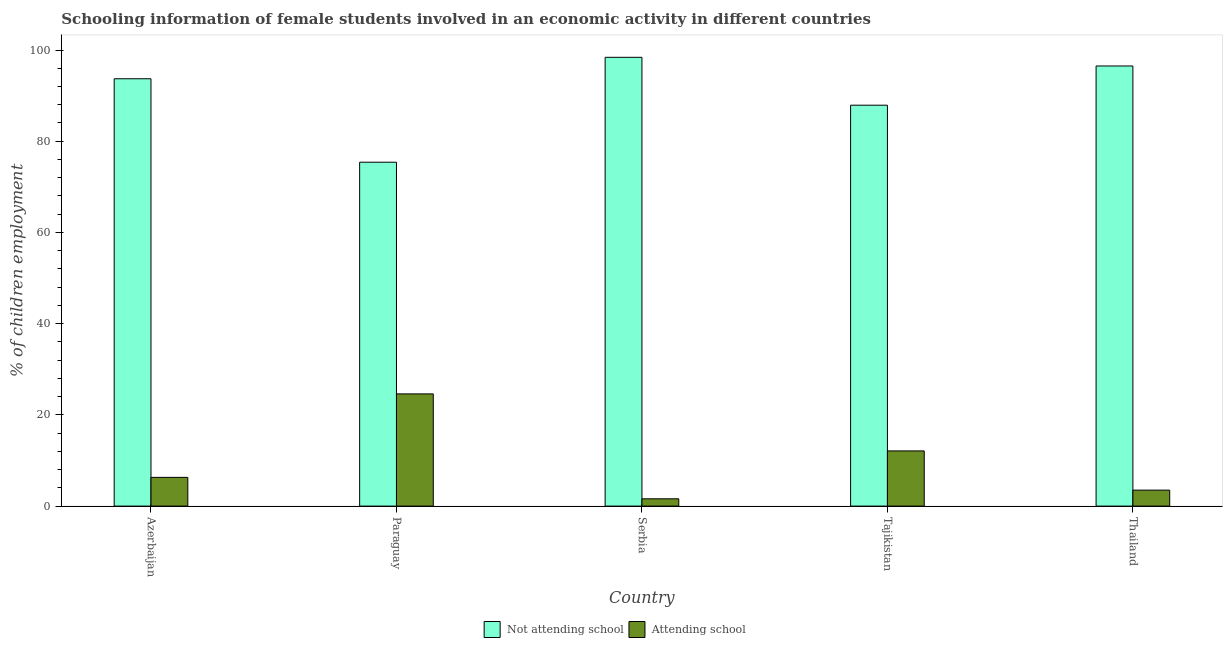Are the number of bars per tick equal to the number of legend labels?
Your answer should be compact. Yes. Are the number of bars on each tick of the X-axis equal?
Keep it short and to the point. Yes. How many bars are there on the 3rd tick from the left?
Ensure brevity in your answer.  2. What is the label of the 1st group of bars from the left?
Give a very brief answer. Azerbaijan. In how many cases, is the number of bars for a given country not equal to the number of legend labels?
Your answer should be compact. 0. What is the percentage of employed females who are not attending school in Thailand?
Offer a very short reply. 96.5. Across all countries, what is the maximum percentage of employed females who are attending school?
Your answer should be very brief. 24.6. Across all countries, what is the minimum percentage of employed females who are not attending school?
Your answer should be compact. 75.4. In which country was the percentage of employed females who are attending school maximum?
Offer a terse response. Paraguay. In which country was the percentage of employed females who are not attending school minimum?
Ensure brevity in your answer.  Paraguay. What is the total percentage of employed females who are not attending school in the graph?
Your response must be concise. 451.9. What is the difference between the percentage of employed females who are not attending school in Paraguay and that in Serbia?
Your answer should be compact. -23. What is the difference between the percentage of employed females who are attending school in Thailand and the percentage of employed females who are not attending school in Azerbaijan?
Your answer should be compact. -90.2. What is the average percentage of employed females who are attending school per country?
Provide a succinct answer. 9.62. What is the difference between the percentage of employed females who are not attending school and percentage of employed females who are attending school in Azerbaijan?
Ensure brevity in your answer.  87.4. What is the ratio of the percentage of employed females who are not attending school in Serbia to that in Tajikistan?
Ensure brevity in your answer.  1.12. Is the percentage of employed females who are attending school in Serbia less than that in Tajikistan?
Offer a very short reply. Yes. Is the difference between the percentage of employed females who are attending school in Paraguay and Serbia greater than the difference between the percentage of employed females who are not attending school in Paraguay and Serbia?
Offer a terse response. Yes. What is the difference between the highest and the second highest percentage of employed females who are not attending school?
Your response must be concise. 1.9. What does the 1st bar from the left in Azerbaijan represents?
Offer a very short reply. Not attending school. What does the 2nd bar from the right in Serbia represents?
Ensure brevity in your answer.  Not attending school. How many countries are there in the graph?
Ensure brevity in your answer.  5. Are the values on the major ticks of Y-axis written in scientific E-notation?
Offer a terse response. No. Where does the legend appear in the graph?
Make the answer very short. Bottom center. What is the title of the graph?
Your response must be concise. Schooling information of female students involved in an economic activity in different countries. What is the label or title of the X-axis?
Provide a succinct answer. Country. What is the label or title of the Y-axis?
Make the answer very short. % of children employment. What is the % of children employment in Not attending school in Azerbaijan?
Your response must be concise. 93.7. What is the % of children employment of Not attending school in Paraguay?
Your answer should be compact. 75.4. What is the % of children employment of Attending school in Paraguay?
Keep it short and to the point. 24.6. What is the % of children employment of Not attending school in Serbia?
Your response must be concise. 98.4. What is the % of children employment in Attending school in Serbia?
Make the answer very short. 1.6. What is the % of children employment of Not attending school in Tajikistan?
Make the answer very short. 87.9. What is the % of children employment of Not attending school in Thailand?
Your response must be concise. 96.5. Across all countries, what is the maximum % of children employment of Not attending school?
Your response must be concise. 98.4. Across all countries, what is the maximum % of children employment of Attending school?
Give a very brief answer. 24.6. Across all countries, what is the minimum % of children employment in Not attending school?
Your response must be concise. 75.4. What is the total % of children employment in Not attending school in the graph?
Your response must be concise. 451.9. What is the total % of children employment in Attending school in the graph?
Give a very brief answer. 48.1. What is the difference between the % of children employment of Attending school in Azerbaijan and that in Paraguay?
Make the answer very short. -18.3. What is the difference between the % of children employment of Attending school in Azerbaijan and that in Serbia?
Provide a succinct answer. 4.7. What is the difference between the % of children employment of Attending school in Azerbaijan and that in Tajikistan?
Provide a succinct answer. -5.8. What is the difference between the % of children employment of Not attending school in Paraguay and that in Serbia?
Your answer should be very brief. -23. What is the difference between the % of children employment in Attending school in Paraguay and that in Serbia?
Give a very brief answer. 23. What is the difference between the % of children employment of Attending school in Paraguay and that in Tajikistan?
Offer a terse response. 12.5. What is the difference between the % of children employment of Not attending school in Paraguay and that in Thailand?
Ensure brevity in your answer.  -21.1. What is the difference between the % of children employment in Attending school in Paraguay and that in Thailand?
Offer a terse response. 21.1. What is the difference between the % of children employment in Not attending school in Serbia and that in Tajikistan?
Make the answer very short. 10.5. What is the difference between the % of children employment in Attending school in Serbia and that in Tajikistan?
Provide a succinct answer. -10.5. What is the difference between the % of children employment of Not attending school in Serbia and that in Thailand?
Make the answer very short. 1.9. What is the difference between the % of children employment of Not attending school in Azerbaijan and the % of children employment of Attending school in Paraguay?
Ensure brevity in your answer.  69.1. What is the difference between the % of children employment in Not attending school in Azerbaijan and the % of children employment in Attending school in Serbia?
Your response must be concise. 92.1. What is the difference between the % of children employment in Not attending school in Azerbaijan and the % of children employment in Attending school in Tajikistan?
Provide a short and direct response. 81.6. What is the difference between the % of children employment of Not attending school in Azerbaijan and the % of children employment of Attending school in Thailand?
Provide a succinct answer. 90.2. What is the difference between the % of children employment in Not attending school in Paraguay and the % of children employment in Attending school in Serbia?
Make the answer very short. 73.8. What is the difference between the % of children employment in Not attending school in Paraguay and the % of children employment in Attending school in Tajikistan?
Offer a very short reply. 63.3. What is the difference between the % of children employment of Not attending school in Paraguay and the % of children employment of Attending school in Thailand?
Offer a very short reply. 71.9. What is the difference between the % of children employment in Not attending school in Serbia and the % of children employment in Attending school in Tajikistan?
Offer a terse response. 86.3. What is the difference between the % of children employment of Not attending school in Serbia and the % of children employment of Attending school in Thailand?
Offer a very short reply. 94.9. What is the difference between the % of children employment of Not attending school in Tajikistan and the % of children employment of Attending school in Thailand?
Provide a short and direct response. 84.4. What is the average % of children employment of Not attending school per country?
Give a very brief answer. 90.38. What is the average % of children employment of Attending school per country?
Give a very brief answer. 9.62. What is the difference between the % of children employment of Not attending school and % of children employment of Attending school in Azerbaijan?
Make the answer very short. 87.4. What is the difference between the % of children employment of Not attending school and % of children employment of Attending school in Paraguay?
Your response must be concise. 50.8. What is the difference between the % of children employment in Not attending school and % of children employment in Attending school in Serbia?
Ensure brevity in your answer.  96.8. What is the difference between the % of children employment of Not attending school and % of children employment of Attending school in Tajikistan?
Provide a succinct answer. 75.8. What is the difference between the % of children employment in Not attending school and % of children employment in Attending school in Thailand?
Keep it short and to the point. 93. What is the ratio of the % of children employment in Not attending school in Azerbaijan to that in Paraguay?
Provide a succinct answer. 1.24. What is the ratio of the % of children employment in Attending school in Azerbaijan to that in Paraguay?
Provide a succinct answer. 0.26. What is the ratio of the % of children employment of Not attending school in Azerbaijan to that in Serbia?
Provide a short and direct response. 0.95. What is the ratio of the % of children employment in Attending school in Azerbaijan to that in Serbia?
Give a very brief answer. 3.94. What is the ratio of the % of children employment of Not attending school in Azerbaijan to that in Tajikistan?
Offer a very short reply. 1.07. What is the ratio of the % of children employment of Attending school in Azerbaijan to that in Tajikistan?
Offer a terse response. 0.52. What is the ratio of the % of children employment of Attending school in Azerbaijan to that in Thailand?
Provide a succinct answer. 1.8. What is the ratio of the % of children employment of Not attending school in Paraguay to that in Serbia?
Make the answer very short. 0.77. What is the ratio of the % of children employment of Attending school in Paraguay to that in Serbia?
Make the answer very short. 15.38. What is the ratio of the % of children employment in Not attending school in Paraguay to that in Tajikistan?
Your answer should be very brief. 0.86. What is the ratio of the % of children employment of Attending school in Paraguay to that in Tajikistan?
Keep it short and to the point. 2.03. What is the ratio of the % of children employment in Not attending school in Paraguay to that in Thailand?
Offer a terse response. 0.78. What is the ratio of the % of children employment in Attending school in Paraguay to that in Thailand?
Your answer should be compact. 7.03. What is the ratio of the % of children employment in Not attending school in Serbia to that in Tajikistan?
Provide a succinct answer. 1.12. What is the ratio of the % of children employment of Attending school in Serbia to that in Tajikistan?
Offer a terse response. 0.13. What is the ratio of the % of children employment of Not attending school in Serbia to that in Thailand?
Keep it short and to the point. 1.02. What is the ratio of the % of children employment in Attending school in Serbia to that in Thailand?
Make the answer very short. 0.46. What is the ratio of the % of children employment of Not attending school in Tajikistan to that in Thailand?
Ensure brevity in your answer.  0.91. What is the ratio of the % of children employment in Attending school in Tajikistan to that in Thailand?
Provide a succinct answer. 3.46. What is the difference between the highest and the second highest % of children employment of Not attending school?
Provide a succinct answer. 1.9. What is the difference between the highest and the second highest % of children employment in Attending school?
Provide a succinct answer. 12.5. What is the difference between the highest and the lowest % of children employment in Not attending school?
Give a very brief answer. 23. 